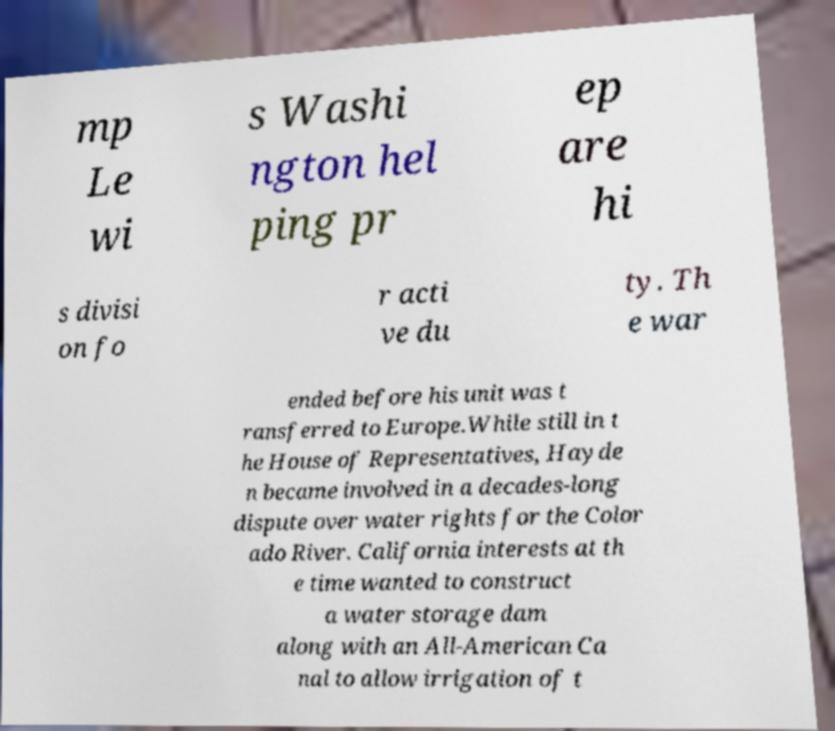I need the written content from this picture converted into text. Can you do that? mp Le wi s Washi ngton hel ping pr ep are hi s divisi on fo r acti ve du ty. Th e war ended before his unit was t ransferred to Europe.While still in t he House of Representatives, Hayde n became involved in a decades-long dispute over water rights for the Color ado River. California interests at th e time wanted to construct a water storage dam along with an All-American Ca nal to allow irrigation of t 